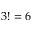Convert formula to latex. <formula><loc_0><loc_0><loc_500><loc_500>3 ! = 6</formula> 